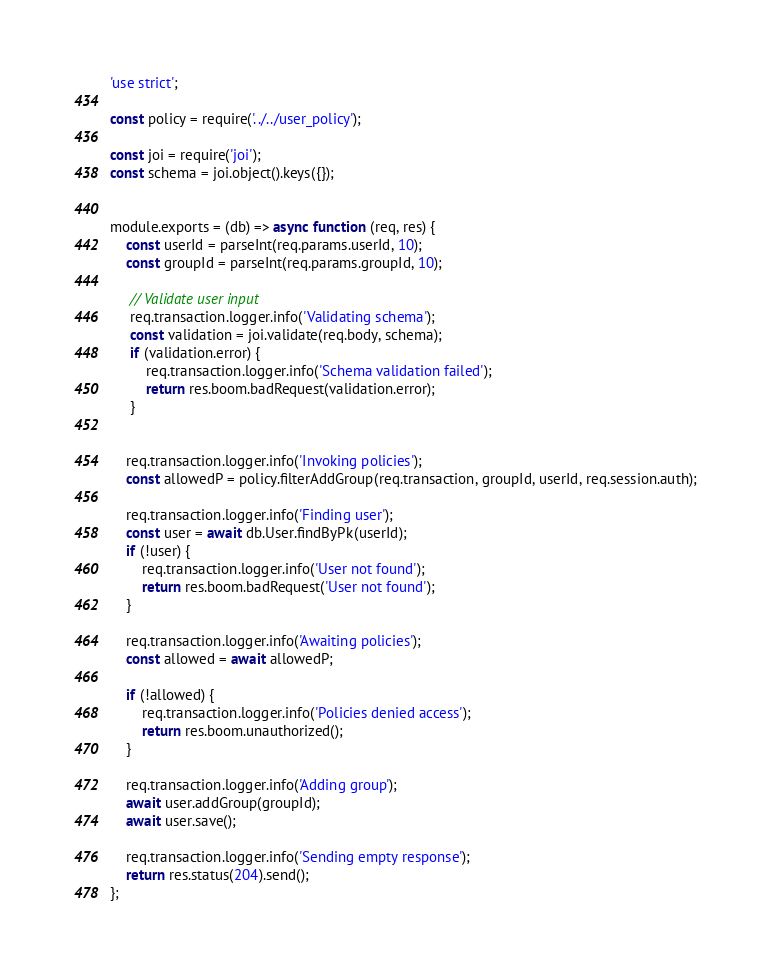<code> <loc_0><loc_0><loc_500><loc_500><_JavaScript_>'use strict';

const policy = require('../../user_policy');

const joi = require('joi');
const schema = joi.object().keys({});


module.exports = (db) => async function (req, res) {
    const userId = parseInt(req.params.userId, 10);
    const groupId = parseInt(req.params.groupId, 10);

     // Validate user input
     req.transaction.logger.info('Validating schema');
     const validation = joi.validate(req.body, schema);
     if (validation.error) {
         req.transaction.logger.info('Schema validation failed');
         return res.boom.badRequest(validation.error);
     }


    req.transaction.logger.info('Invoking policies');
    const allowedP = policy.filterAddGroup(req.transaction, groupId, userId, req.session.auth);

    req.transaction.logger.info('Finding user');
    const user = await db.User.findByPk(userId);
    if (!user) {
        req.transaction.logger.info('User not found');
        return res.boom.badRequest('User not found');
    }

    req.transaction.logger.info('Awaiting policies');
    const allowed = await allowedP;

    if (!allowed) {
        req.transaction.logger.info('Policies denied access');
        return res.boom.unauthorized();
    }

    req.transaction.logger.info('Adding group');
    await user.addGroup(groupId);
    await user.save();

    req.transaction.logger.info('Sending empty response');
    return res.status(204).send();
};
</code> 